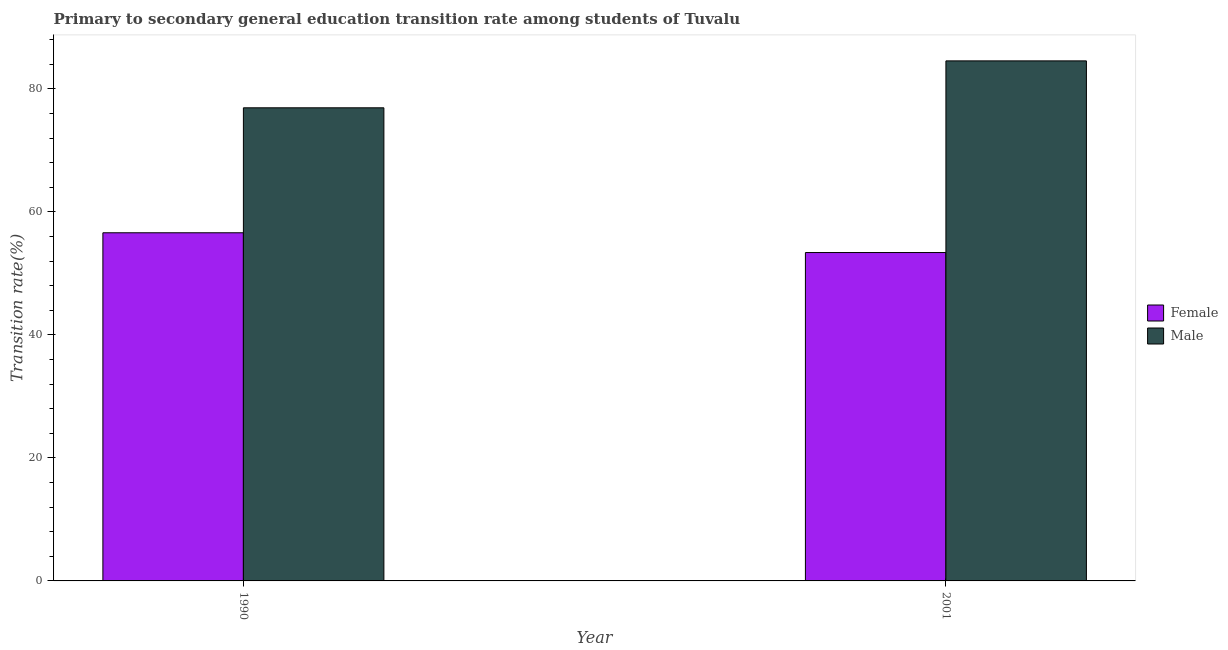Are the number of bars on each tick of the X-axis equal?
Give a very brief answer. Yes. How many bars are there on the 1st tick from the left?
Ensure brevity in your answer.  2. How many bars are there on the 2nd tick from the right?
Your response must be concise. 2. In how many cases, is the number of bars for a given year not equal to the number of legend labels?
Your answer should be very brief. 0. What is the transition rate among male students in 1990?
Your response must be concise. 76.92. Across all years, what is the maximum transition rate among female students?
Make the answer very short. 56.6. Across all years, what is the minimum transition rate among male students?
Give a very brief answer. 76.92. In which year was the transition rate among female students maximum?
Ensure brevity in your answer.  1990. What is the total transition rate among male students in the graph?
Ensure brevity in your answer.  161.48. What is the difference between the transition rate among female students in 1990 and that in 2001?
Offer a terse response. 3.21. What is the difference between the transition rate among female students in 1990 and the transition rate among male students in 2001?
Your answer should be very brief. 3.21. What is the average transition rate among male students per year?
Provide a short and direct response. 80.74. In the year 2001, what is the difference between the transition rate among female students and transition rate among male students?
Offer a very short reply. 0. What is the ratio of the transition rate among female students in 1990 to that in 2001?
Your answer should be very brief. 1.06. In how many years, is the transition rate among female students greater than the average transition rate among female students taken over all years?
Provide a short and direct response. 1. What does the 1st bar from the right in 1990 represents?
Provide a succinct answer. Male. What is the difference between two consecutive major ticks on the Y-axis?
Offer a terse response. 20. How many legend labels are there?
Your answer should be very brief. 2. What is the title of the graph?
Give a very brief answer. Primary to secondary general education transition rate among students of Tuvalu. What is the label or title of the X-axis?
Ensure brevity in your answer.  Year. What is the label or title of the Y-axis?
Offer a very short reply. Transition rate(%). What is the Transition rate(%) of Female in 1990?
Offer a very short reply. 56.6. What is the Transition rate(%) in Male in 1990?
Your response must be concise. 76.92. What is the Transition rate(%) of Female in 2001?
Your answer should be compact. 53.39. What is the Transition rate(%) in Male in 2001?
Make the answer very short. 84.55. Across all years, what is the maximum Transition rate(%) in Female?
Your answer should be compact. 56.6. Across all years, what is the maximum Transition rate(%) in Male?
Provide a short and direct response. 84.55. Across all years, what is the minimum Transition rate(%) of Female?
Offer a terse response. 53.39. Across all years, what is the minimum Transition rate(%) in Male?
Provide a succinct answer. 76.92. What is the total Transition rate(%) of Female in the graph?
Provide a short and direct response. 109.99. What is the total Transition rate(%) in Male in the graph?
Your answer should be compact. 161.48. What is the difference between the Transition rate(%) in Female in 1990 and that in 2001?
Your answer should be very brief. 3.21. What is the difference between the Transition rate(%) in Male in 1990 and that in 2001?
Provide a succinct answer. -7.63. What is the difference between the Transition rate(%) of Female in 1990 and the Transition rate(%) of Male in 2001?
Provide a short and direct response. -27.95. What is the average Transition rate(%) of Female per year?
Your response must be concise. 55. What is the average Transition rate(%) of Male per year?
Your answer should be very brief. 80.74. In the year 1990, what is the difference between the Transition rate(%) in Female and Transition rate(%) in Male?
Give a very brief answer. -20.32. In the year 2001, what is the difference between the Transition rate(%) of Female and Transition rate(%) of Male?
Ensure brevity in your answer.  -31.16. What is the ratio of the Transition rate(%) of Female in 1990 to that in 2001?
Keep it short and to the point. 1.06. What is the ratio of the Transition rate(%) of Male in 1990 to that in 2001?
Keep it short and to the point. 0.91. What is the difference between the highest and the second highest Transition rate(%) in Female?
Your answer should be very brief. 3.21. What is the difference between the highest and the second highest Transition rate(%) in Male?
Offer a very short reply. 7.63. What is the difference between the highest and the lowest Transition rate(%) in Female?
Keep it short and to the point. 3.21. What is the difference between the highest and the lowest Transition rate(%) of Male?
Make the answer very short. 7.63. 